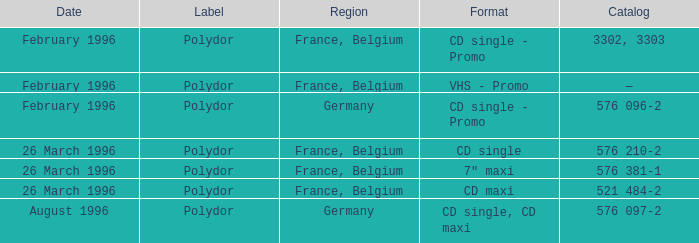Specify the directory for march 26, 199 576 210-2, 576 381-1, 521 484-2. Help me parse the entirety of this table. {'header': ['Date', 'Label', 'Region', 'Format', 'Catalog'], 'rows': [['February 1996', 'Polydor', 'France, Belgium', 'CD single - Promo', '3302, 3303'], ['February 1996', 'Polydor', 'France, Belgium', 'VHS - Promo', '—'], ['February 1996', 'Polydor', 'Germany', 'CD single - Promo', '576 096-2'], ['26 March 1996', 'Polydor', 'France, Belgium', 'CD single', '576 210-2'], ['26 March 1996', 'Polydor', 'France, Belgium', '7" maxi', '576 381-1'], ['26 March 1996', 'Polydor', 'France, Belgium', 'CD maxi', '521 484-2'], ['August 1996', 'Polydor', 'Germany', 'CD single, CD maxi', '576 097-2']]} 